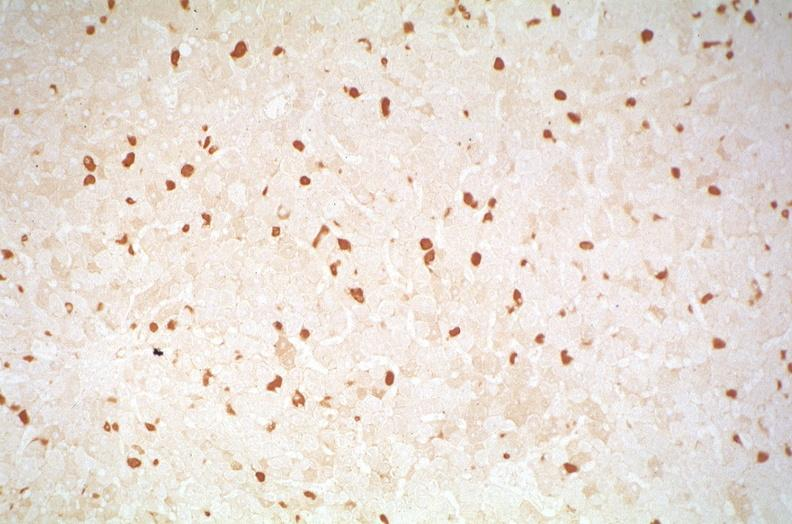s hepatobiliary present?
Answer the question using a single word or phrase. Yes 